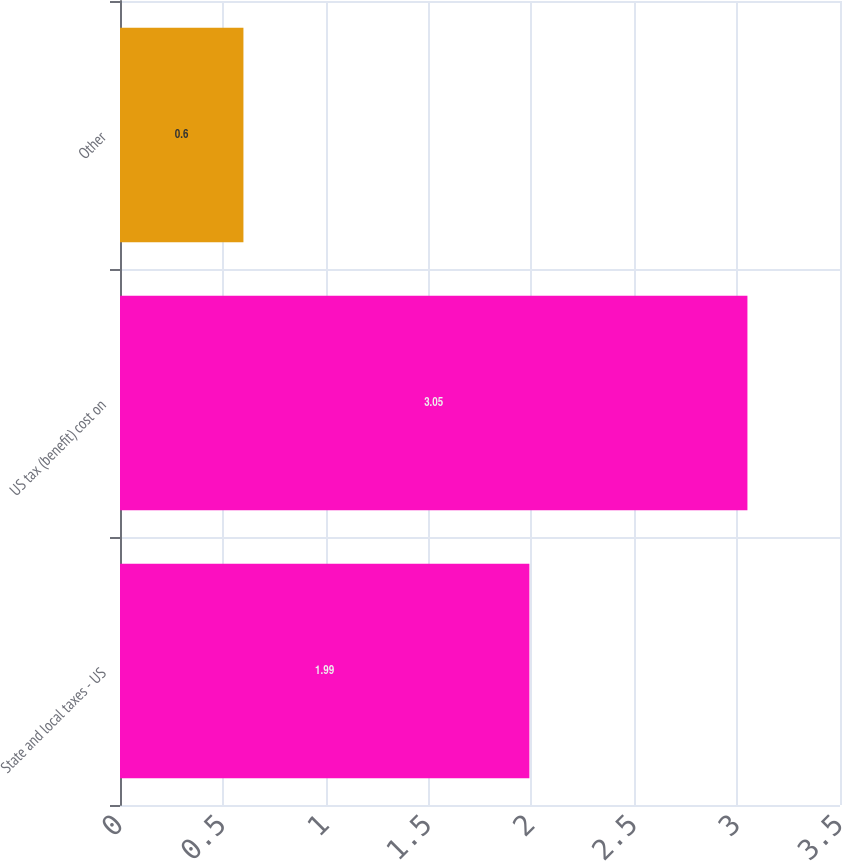<chart> <loc_0><loc_0><loc_500><loc_500><bar_chart><fcel>State and local taxes - US<fcel>US tax (benefit) cost on<fcel>Other<nl><fcel>1.99<fcel>3.05<fcel>0.6<nl></chart> 